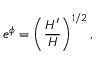<formula> <loc_0><loc_0><loc_500><loc_500>e ^ { \phi } = \left ( \frac { H ^ { \prime } } { H } \right ) ^ { 1 / 2 } ,</formula> 